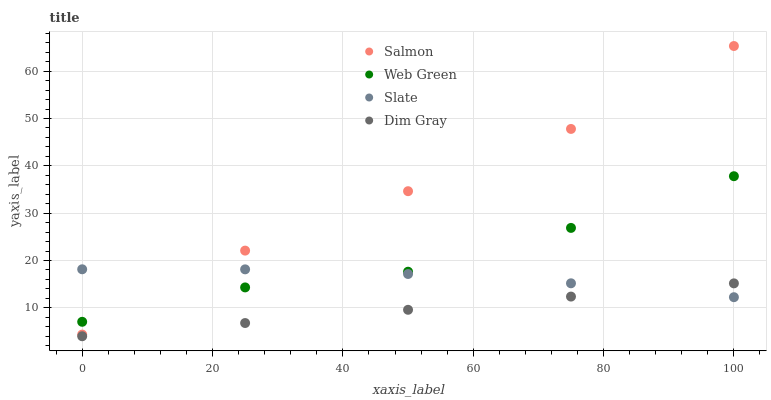Does Dim Gray have the minimum area under the curve?
Answer yes or no. Yes. Does Salmon have the maximum area under the curve?
Answer yes or no. Yes. Does Salmon have the minimum area under the curve?
Answer yes or no. No. Does Dim Gray have the maximum area under the curve?
Answer yes or no. No. Is Dim Gray the smoothest?
Answer yes or no. Yes. Is Web Green the roughest?
Answer yes or no. Yes. Is Salmon the smoothest?
Answer yes or no. No. Is Salmon the roughest?
Answer yes or no. No. Does Dim Gray have the lowest value?
Answer yes or no. Yes. Does Salmon have the lowest value?
Answer yes or no. No. Does Salmon have the highest value?
Answer yes or no. Yes. Does Dim Gray have the highest value?
Answer yes or no. No. Is Dim Gray less than Salmon?
Answer yes or no. Yes. Is Salmon greater than Dim Gray?
Answer yes or no. Yes. Does Slate intersect Salmon?
Answer yes or no. Yes. Is Slate less than Salmon?
Answer yes or no. No. Is Slate greater than Salmon?
Answer yes or no. No. Does Dim Gray intersect Salmon?
Answer yes or no. No. 